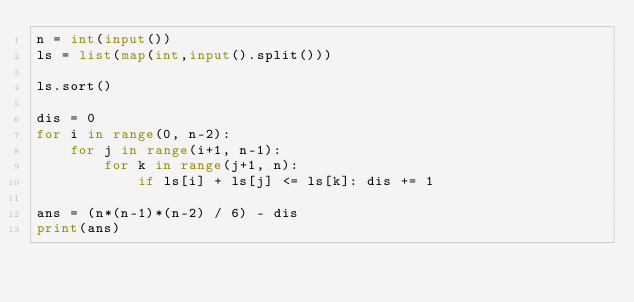<code> <loc_0><loc_0><loc_500><loc_500><_Python_>n = int(input())
ls = list(map(int,input().split()))

ls.sort()

dis = 0
for i in range(0, n-2):
    for j in range(i+1, n-1):
        for k in range(j+1, n):
            if ls[i] + ls[j] <= ls[k]: dis += 1

ans = (n*(n-1)*(n-2) / 6) - dis
print(ans)</code> 